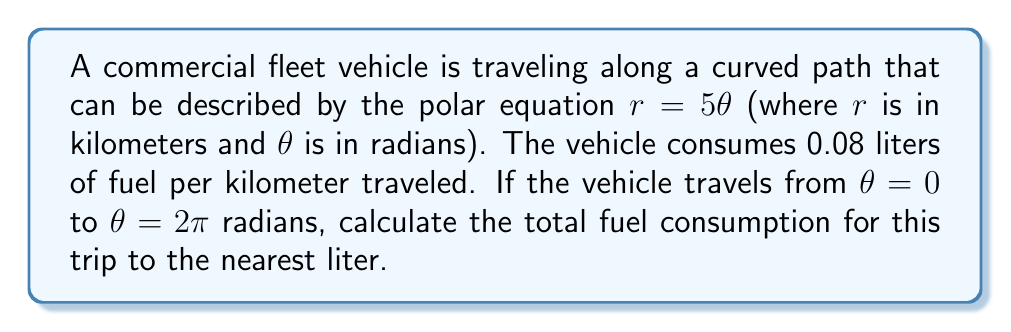Teach me how to tackle this problem. To solve this problem, we need to follow these steps:

1) First, we need to calculate the length of the path traveled. In polar coordinates, the arc length formula is:

   $$L = \int_a^b \sqrt{r^2 + \left(\frac{dr}{d\theta}\right)^2} d\theta$$

2) For our equation $r = 5\theta$, we have $\frac{dr}{d\theta} = 5$. Substituting into the formula:

   $$L = \int_0^{2\pi} \sqrt{(5\theta)^2 + 5^2} d\theta$$

3) Simplifying under the square root:

   $$L = \int_0^{2\pi} \sqrt{25\theta^2 + 25} d\theta = 5\int_0^{2\pi} \sqrt{\theta^2 + 1} d\theta$$

4) This integral doesn't have an elementary antiderivative. We can solve it using the substitution $\theta = \sinh u$:

   $$L = 5\int_0^{\sinh^{-1}(2\pi)} \sqrt{\sinh^2 u + 1} \cosh u du = 5\int_0^{\sinh^{-1}(2\pi)} \cosh^2 u du$$

5) The antiderivative of $\cosh^2 u$ is $\frac{1}{2}(u + \sinh u \cosh u)$. Evaluating:

   $$L = \frac{5}{2}[u + \sinh u \cosh u]_0^{\sinh^{-1}(2\pi)}$$

6) Simplifying and evaluating (you would typically use a calculator for this step):

   $$L \approx 99.35 \text{ km}$$

7) Now that we know the distance traveled, we can calculate the fuel consumption:

   Fuel consumption = Distance × Fuel consumption rate
                    $= 99.35 \text{ km} \times 0.08 \text{ L/km} = 7.948 \text{ L}$

8) Rounding to the nearest liter:

   Fuel consumption $\approx 8 \text{ L}$
Answer: 8 liters 